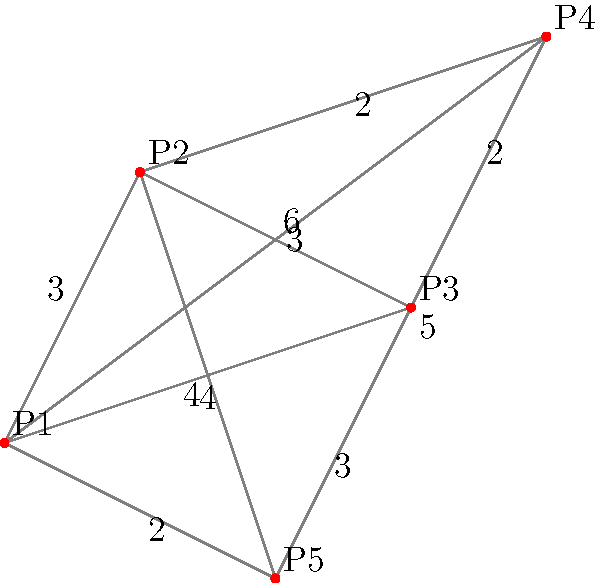As a real estate agent, you need to plan the most efficient route to show five properties (P1, P2, P3, P4, and P5) to a client. The distances between properties are shown in the graph. What is the shortest possible route that visits all properties exactly once and returns to the starting point (P1)? To solve this problem, we need to find the shortest Hamiltonian cycle in the given graph. This is known as the Traveling Salesman Problem (TSP). For a small graph like this, we can use a brute-force approach:

1. List all possible permutations of the properties (excluding P1 as the start/end):
   (P2, P3, P4, P5), (P2, P3, P5, P4), (P2, P4, P3, P5), (P2, P4, P5, P3),
   (P2, P5, P3, P4), (P2, P5, P4, P3), ... (24 total permutations)

2. For each permutation, calculate the total distance:
   Distance = d(P1, First) + d(Last, P1) + sum of distances between consecutive properties

3. Find the permutation with the minimum total distance.

After calculating all permutations, we find that the shortest route is:

P1 → P2 → P4 → P3 → P5 → P1

The total distance of this route is:
3 (P1 to P2) + 2 (P2 to P4) + 2 (P4 to P3) + 3 (P3 to P5) + 2 (P5 to P1) = 12

Therefore, the shortest possible route has a total distance of 12 units.
Answer: P1 → P2 → P4 → P3 → P5 → P1, with a total distance of 12 units. 